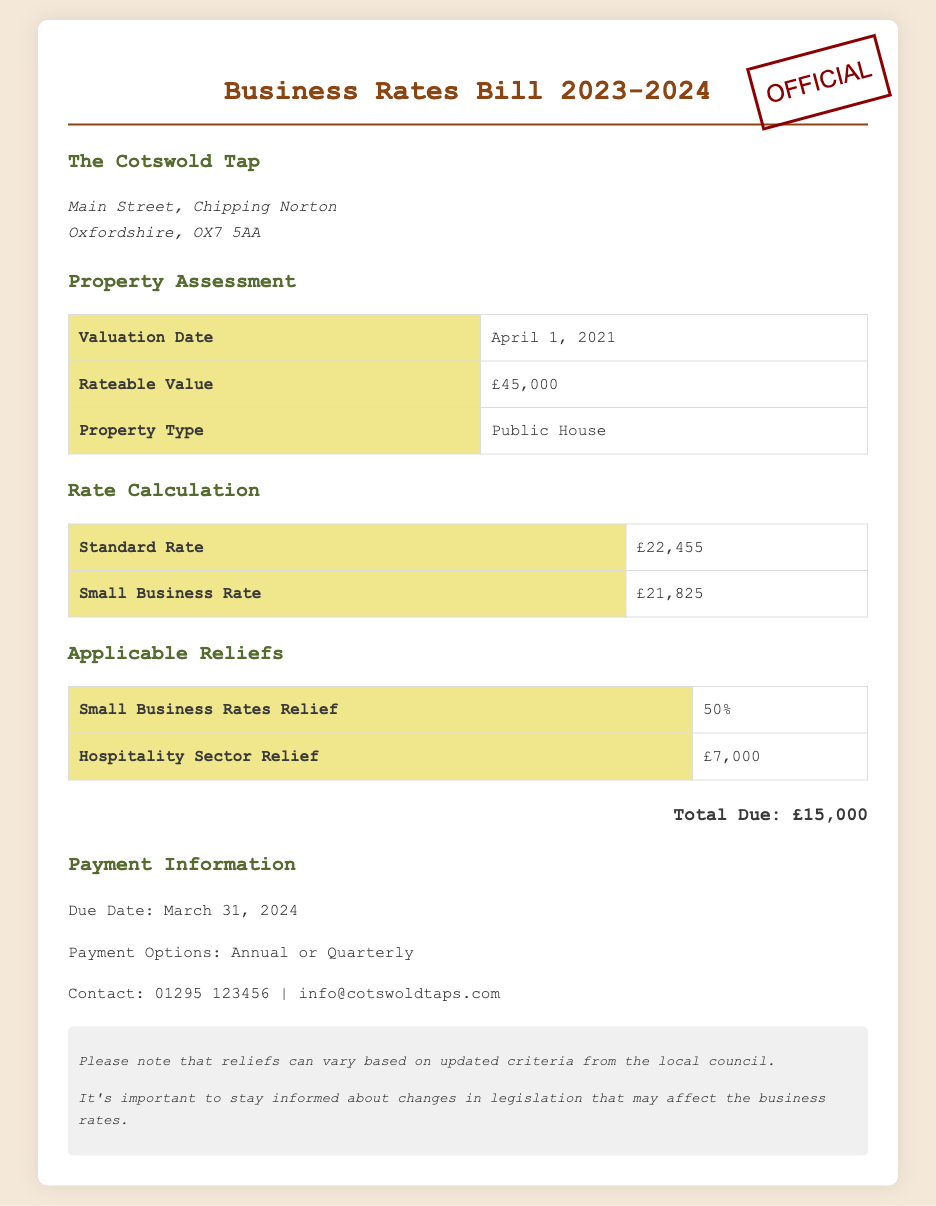What is the rateable value? The rateable value is listed in the property assessment section, which indicates the assessed value of the property for tax purposes.
Answer: £45,000 When is the due date for payment? The due date is specified in the payment information section of the document.
Answer: March 31, 2024 What type of property is assessed in this bill? The property type is mentioned in the property assessment section, specifying the usage of the space.
Answer: Public House How much relief does the Small Business Rates Relief provide? The percentage of relief is detailed in the applicable reliefs section, reflecting the support available for businesses like yours.
Answer: 50% What is the total amount due? The total due amount is explicitly stated in the total due section of the document.
Answer: £15,000 What is the standard rate amount? The standard rate is listed in the rate calculation table, providing detailed financial obligations.
Answer: £22,455 What relief is available specifically for the hospitality sector? The relief for the hospitality sector is mentioned in the applicable reliefs section, indicating support aimed at businesses in that category.
Answer: £7,000 What options are available for making payments? The payment options are outlined in the payment information section, stating how the bill can be settled.
Answer: Annual or Quarterly When was the valuation date for this property? The valuation date is indicated in the property assessment section, marking when the property was last evaluated.
Answer: April 1, 2021 